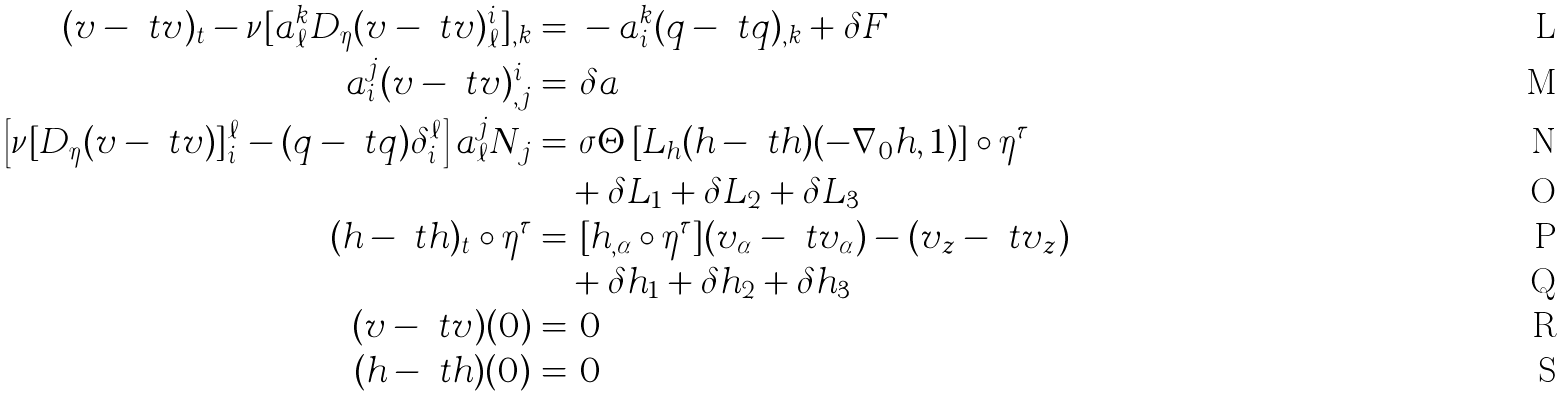Convert formula to latex. <formula><loc_0><loc_0><loc_500><loc_500>( v - \ t v ) _ { t } - \nu [ a _ { \ell } ^ { k } D _ { \eta } ( v - \ t v ) _ { \ell } ^ { i } ] _ { , k } = & \ - a _ { i } ^ { k } ( q - \ t q ) _ { , k } + \delta F \\ a _ { i } ^ { j } ( v - \ t v ) _ { , j } ^ { i } = & \ \delta a \\ \left [ \nu [ D _ { \eta } ( v - \ t v ) ] _ { i } ^ { \ell } - ( q - \ t q ) \delta _ { i } ^ { \ell } \right ] a _ { \ell } ^ { j } N _ { j } = & \ \sigma \Theta \left [ L _ { h } ( h - \ t h ) ( - \nabla _ { 0 } h , 1 ) \right ] \circ \eta ^ { \tau } \\ & + \delta L _ { 1 } + \delta L _ { 2 } + \delta L _ { 3 } \\ ( h - \ t h ) _ { t } \circ \eta ^ { \tau } = & \ [ h _ { , \alpha } \circ \eta ^ { \tau } ] ( v _ { \alpha } - \ t v _ { \alpha } ) - ( v _ { z } - \ t v _ { z } ) \\ & + \delta h _ { 1 } + \delta h _ { 2 } + \delta h _ { 3 } \\ ( v - \ t v ) ( 0 ) = & \ 0 \\ ( h - \ t h ) ( 0 ) = & \ 0</formula> 